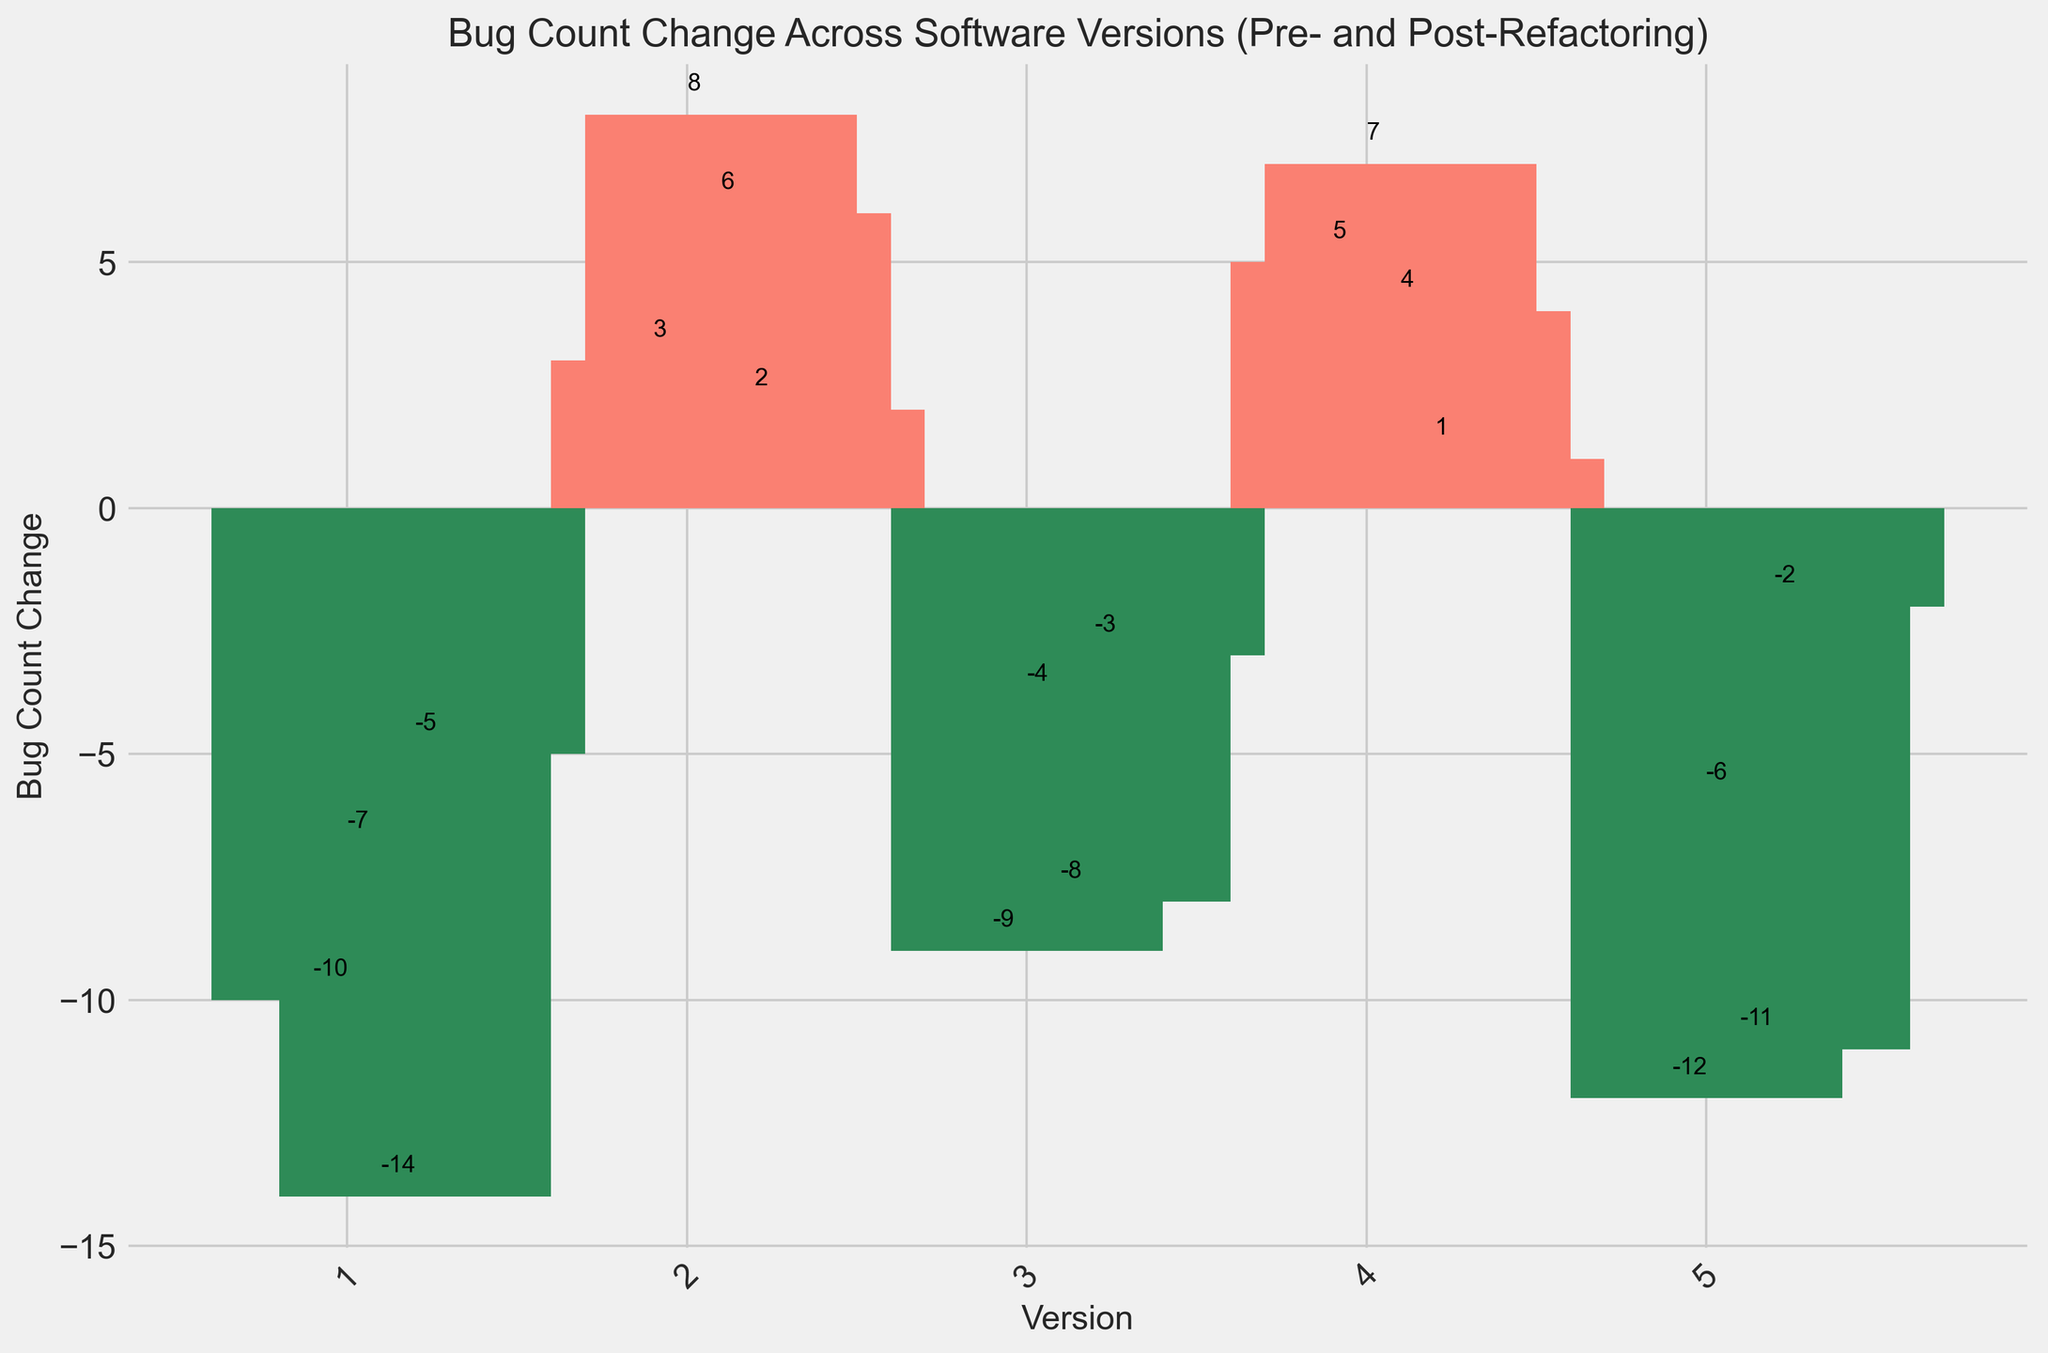Which version has the highest positive bug count change? The height of the bars indicates the bug count change. The tallest bar above the x-axis corresponds to the highest positive bug count change, which is version 2.1 with a count of 8.
Answer: 2.1 How many versions have negative bug count changes? Count the number of bars below the x-axis. There are 12 versions (1.0, 1.1, 1.2, 1.3, 3.0, 3.1, 3.2, 3.3, 5.0, 5.1, 5.2, 5.3) with negative bug count changes.
Answer: 12 What’s the average bug count change for all versions after version 3.0? Calculate the average bug count change for versions 4.0, 4.1, 4.2, 4.3, 5.0, 5.1, 5.2, and 5.3. The values are (5 + 7 + 4 + 1 - 12 - 6 - 11 - 2)/8 = -14/8 = -1.75.
Answer: -1.75 Which version experienced the greatest decrease in bugs? Identify the bar with the lowest height below the x-axis. Version 1.2 has the greatest decrease in bugs with a count of -14.
Answer: 1.2 Which versions have less than -5 bug count changes but more than -10? Find the bars between -5 and -10 on the negative side. The versions that meet this criteria are 1.1, 3.1, and 5.1.
Answer: 1.1, 3.1, 5.1 What is the total bug count change for versions 2.1, 2.2, and 2.3? Add the bug count changes for these versions. The values are 8 (2.1) + 6 (2.2) + 2 (2.3) = 16.
Answer: 16 Which version has the smallest negative bug count change? Identify the tallest bar below the x-axis closest to zero. Version 5.3 has the smallest negative bug count change with a count of -2.
Answer: 5.3 What is the total bug count change for versions with positive values? Add up the counts for all positive change values (2.0, 2.1, 2.2, 2.3, 4.0, 4.1, 4.2, 4.3). The values are 3 + 8 + 6 + 2 + 5 + 7 + 4 + 1 = 36.
Answer: 36 How many versions have a positive bug count change greater than or equal to 5? Count the number of bars that meet this criteria. The versions are 2.0, 2.1, 2.2, 4.0, 4.1.
Answer: 5 